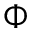<formula> <loc_0><loc_0><loc_500><loc_500>\Phi</formula> 